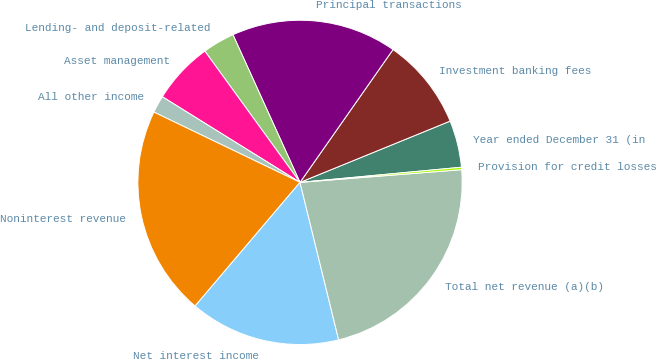Convert chart. <chart><loc_0><loc_0><loc_500><loc_500><pie_chart><fcel>Year ended December 31 (in<fcel>Investment banking fees<fcel>Principal transactions<fcel>Lending- and deposit-related<fcel>Asset management<fcel>All other income<fcel>Noninterest revenue<fcel>Net interest income<fcel>Total net revenue (a)(b)<fcel>Provision for credit losses<nl><fcel>4.68%<fcel>9.11%<fcel>16.51%<fcel>3.2%<fcel>6.16%<fcel>1.72%<fcel>20.94%<fcel>15.03%<fcel>22.42%<fcel>0.24%<nl></chart> 